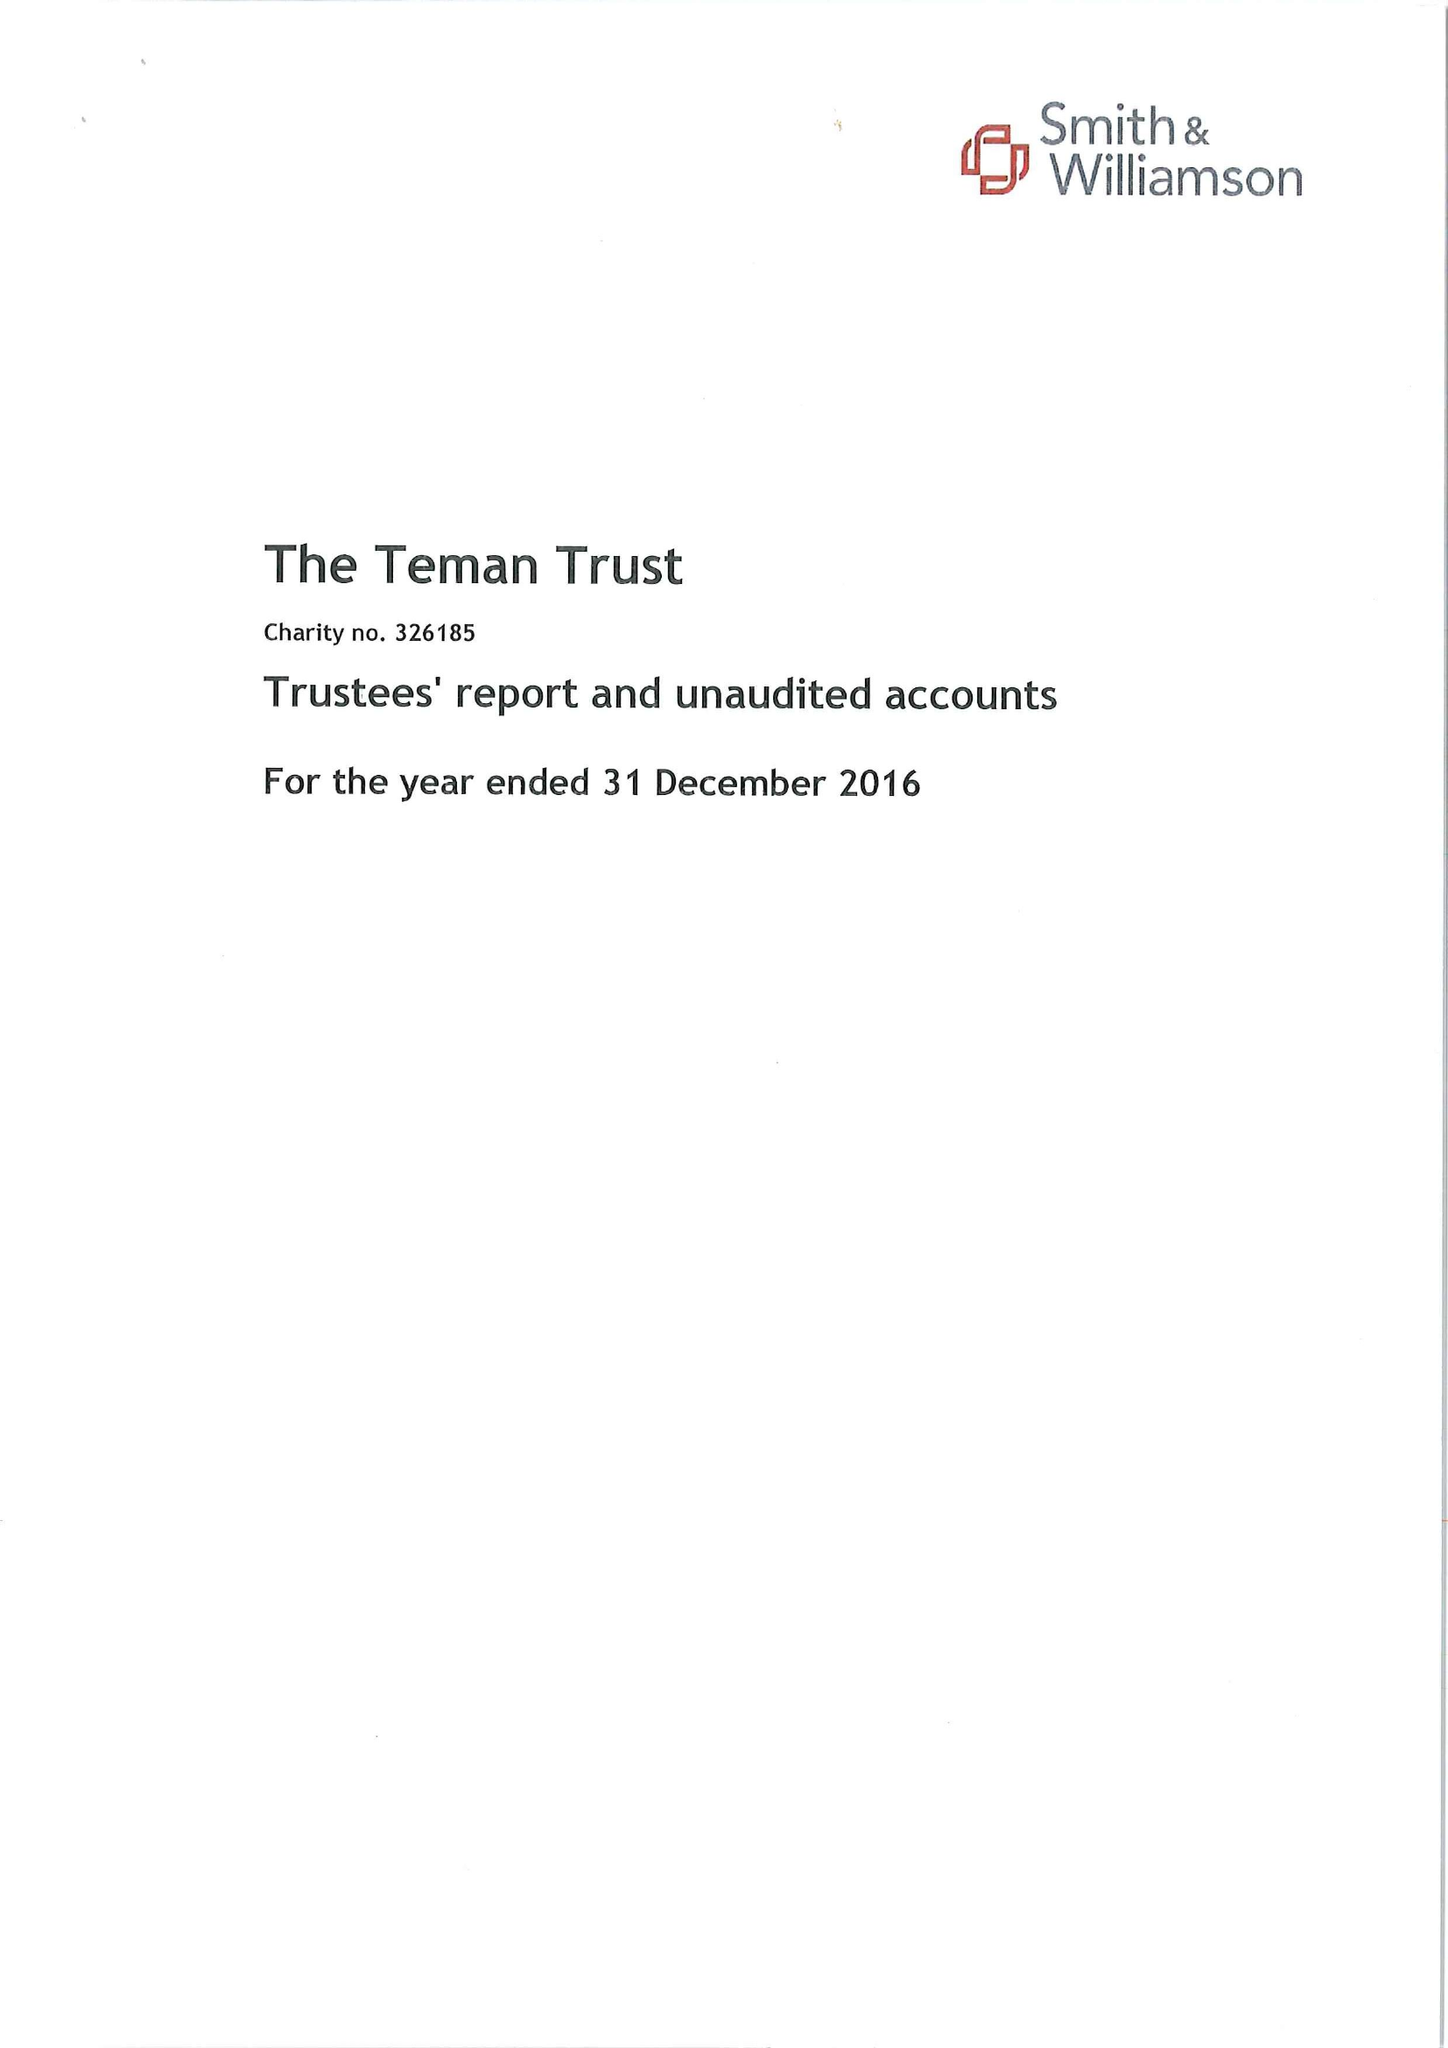What is the value for the address__postcode?
Answer the question using a single word or phrase. SO15 2NS 